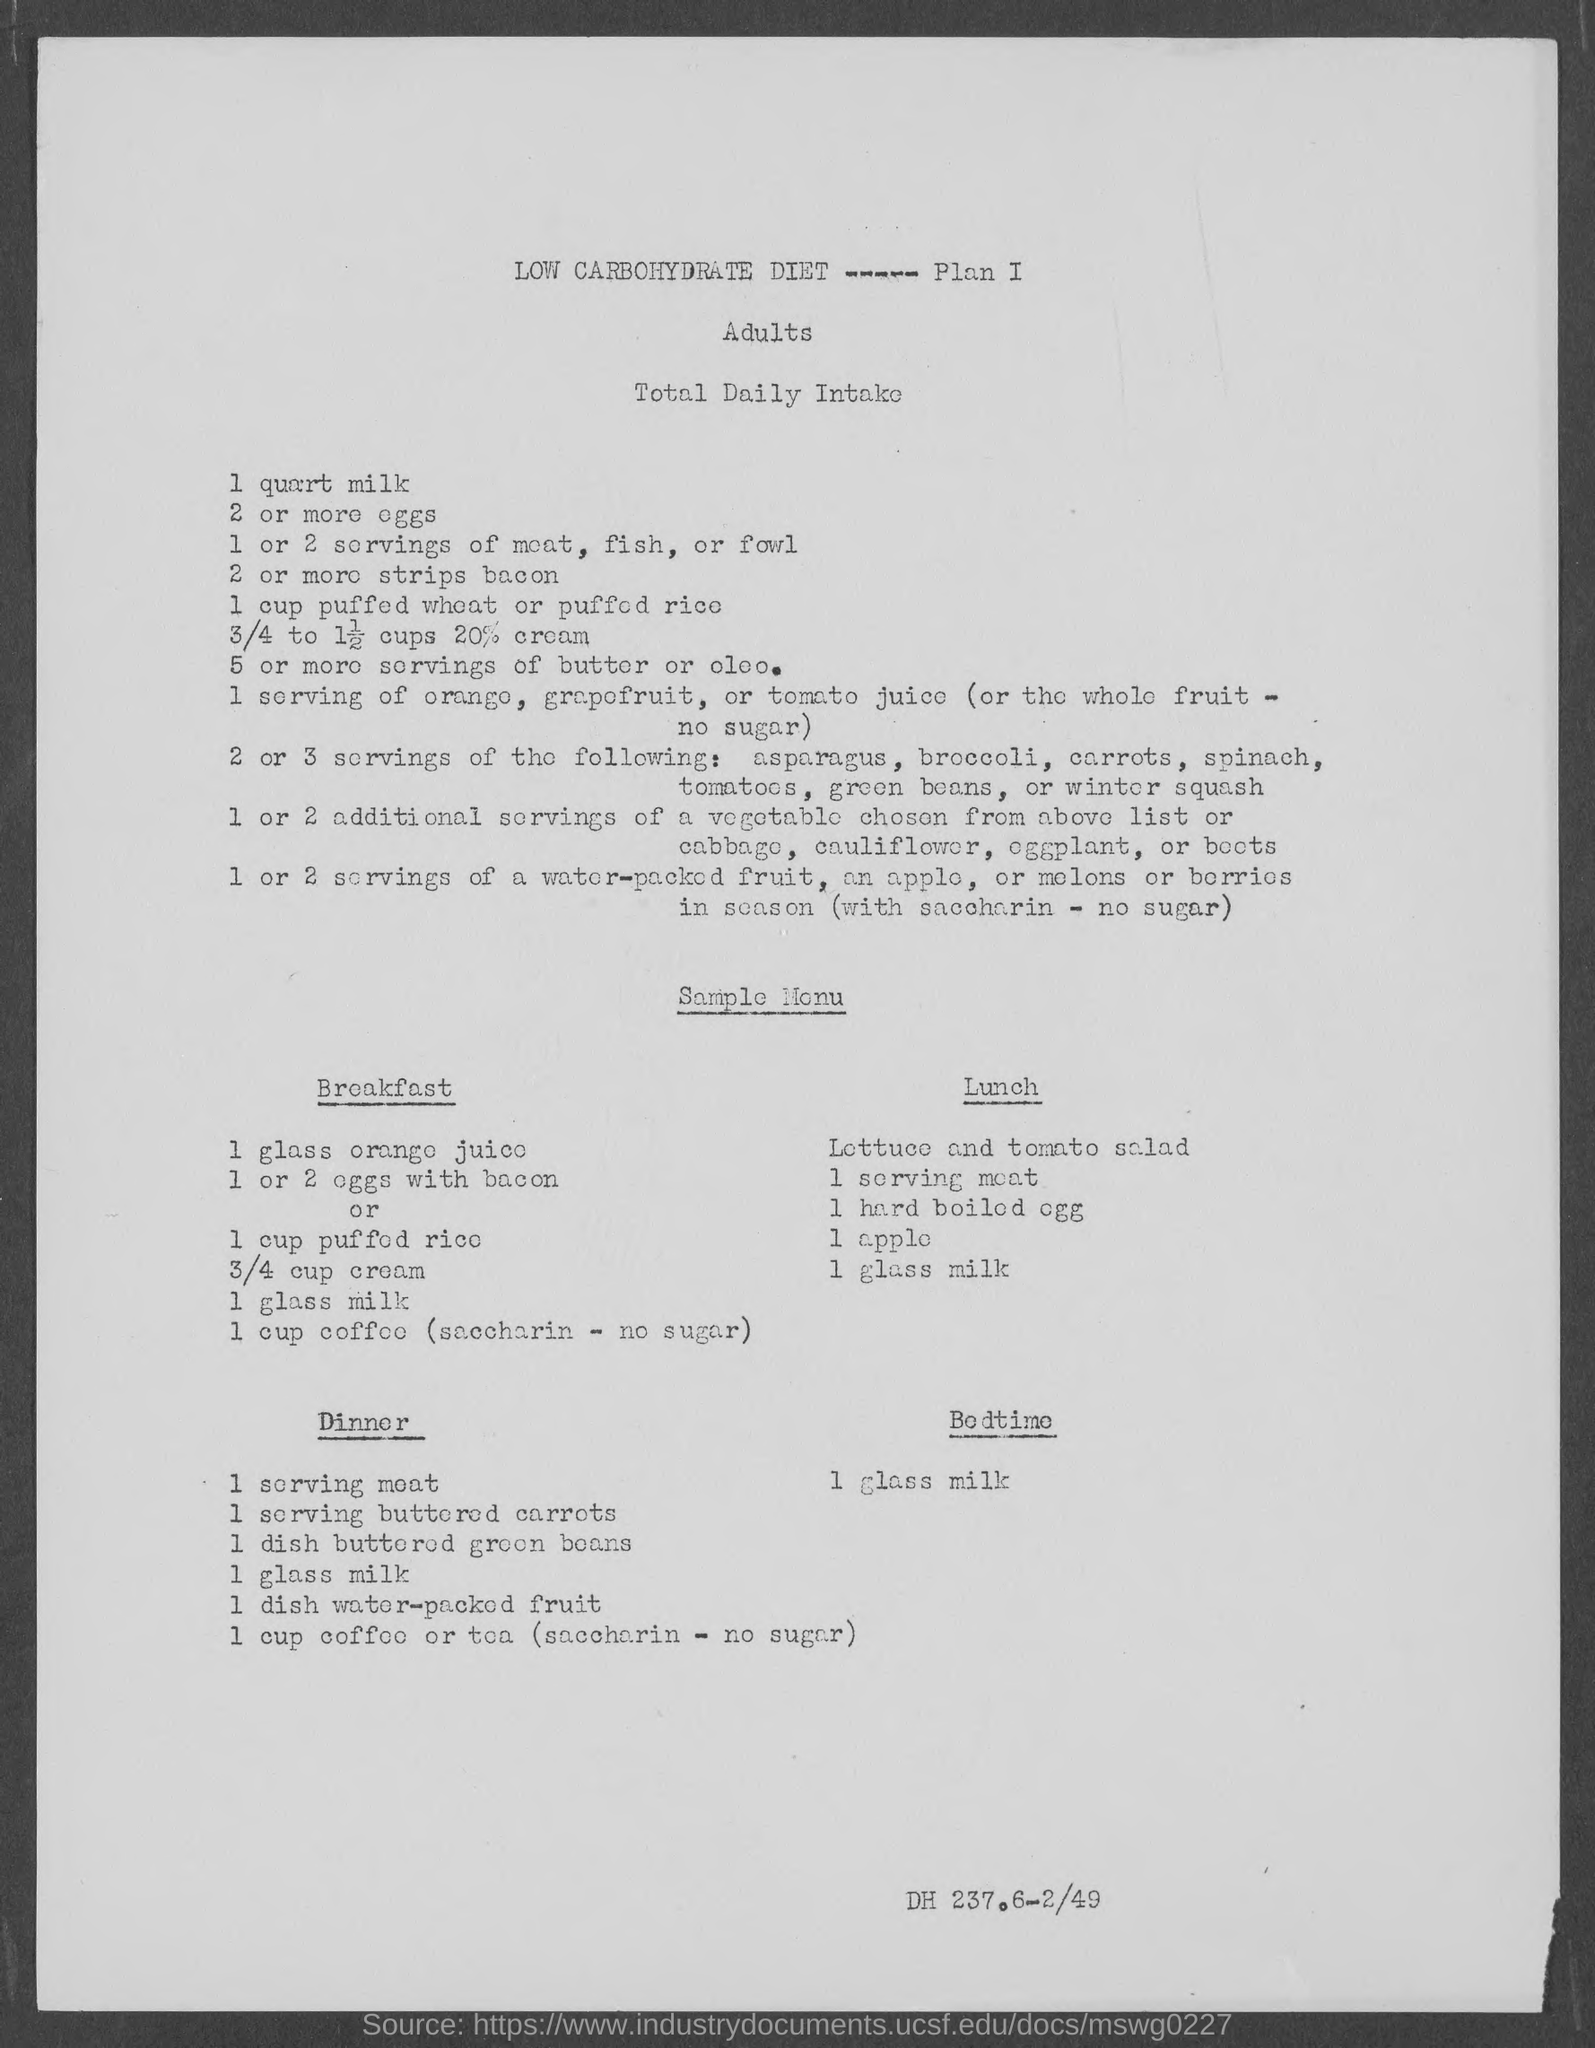Indicate a few pertinent items in this graphic. According to the diet plan, the second item for breakfast is either 1 or 2 eggs with bacon or 1 cup of puffed rice. According to the diet plan, the first item for lunch is a lettuce and tomato salad. According to the diet plan, the fourth item for lunch is one apple. The diet plan given here is for adults. It is recommended to consume a glass of milk before going to bed as part of a healthy bedtime routine. 